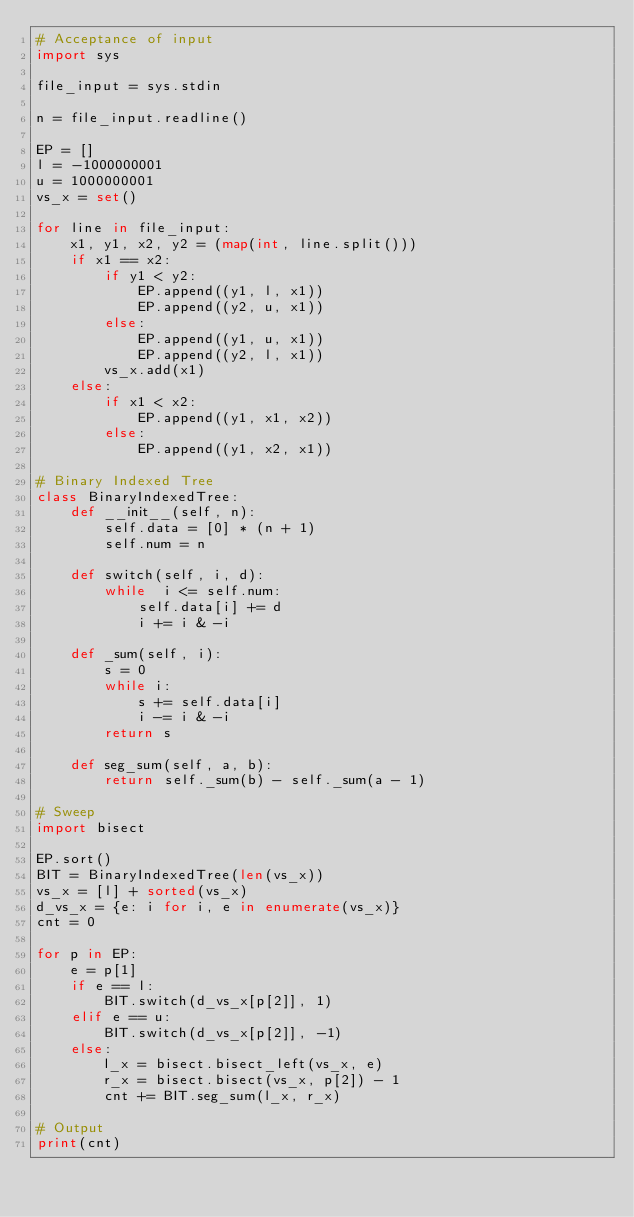Convert code to text. <code><loc_0><loc_0><loc_500><loc_500><_Python_># Acceptance of input
import sys

file_input = sys.stdin

n = file_input.readline()

EP = []
l = -1000000001
u = 1000000001
vs_x = set()

for line in file_input:
    x1, y1, x2, y2 = (map(int, line.split()))
    if x1 == x2:
        if y1 < y2:
            EP.append((y1, l, x1))
            EP.append((y2, u, x1))
        else:
            EP.append((y1, u, x1))
            EP.append((y2, l, x1))
        vs_x.add(x1)
    else:
        if x1 < x2:
            EP.append((y1, x1, x2))
        else:
            EP.append((y1, x2, x1))

# Binary Indexed Tree
class BinaryIndexedTree:
    def __init__(self, n):
        self.data = [0] * (n + 1)
        self.num = n

    def switch(self, i, d):
        while  i <= self.num:
            self.data[i] += d
            i += i & -i

    def _sum(self, i):
        s = 0
        while i:
            s += self.data[i]
            i -= i & -i
        return s

    def seg_sum(self, a, b):
        return self._sum(b) - self._sum(a - 1)

# Sweep
import bisect

EP.sort()
BIT = BinaryIndexedTree(len(vs_x))
vs_x = [l] + sorted(vs_x)
d_vs_x = {e: i for i, e in enumerate(vs_x)}
cnt = 0

for p in EP:
    e = p[1]
    if e == l:
        BIT.switch(d_vs_x[p[2]], 1)
    elif e == u:
        BIT.switch(d_vs_x[p[2]], -1)
    else:
        l_x = bisect.bisect_left(vs_x, e)
        r_x = bisect.bisect(vs_x, p[2]) - 1
        cnt += BIT.seg_sum(l_x, r_x)

# Output
print(cnt)</code> 